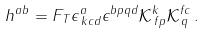<formula> <loc_0><loc_0><loc_500><loc_500>h ^ { a b } = F _ { T } \epsilon ^ { a } _ { \, k c d } \epsilon ^ { b p q d } \mathcal { K } ^ { k } _ { \, f p } \mathcal { K } ^ { f c } _ { \, q } \, .</formula> 